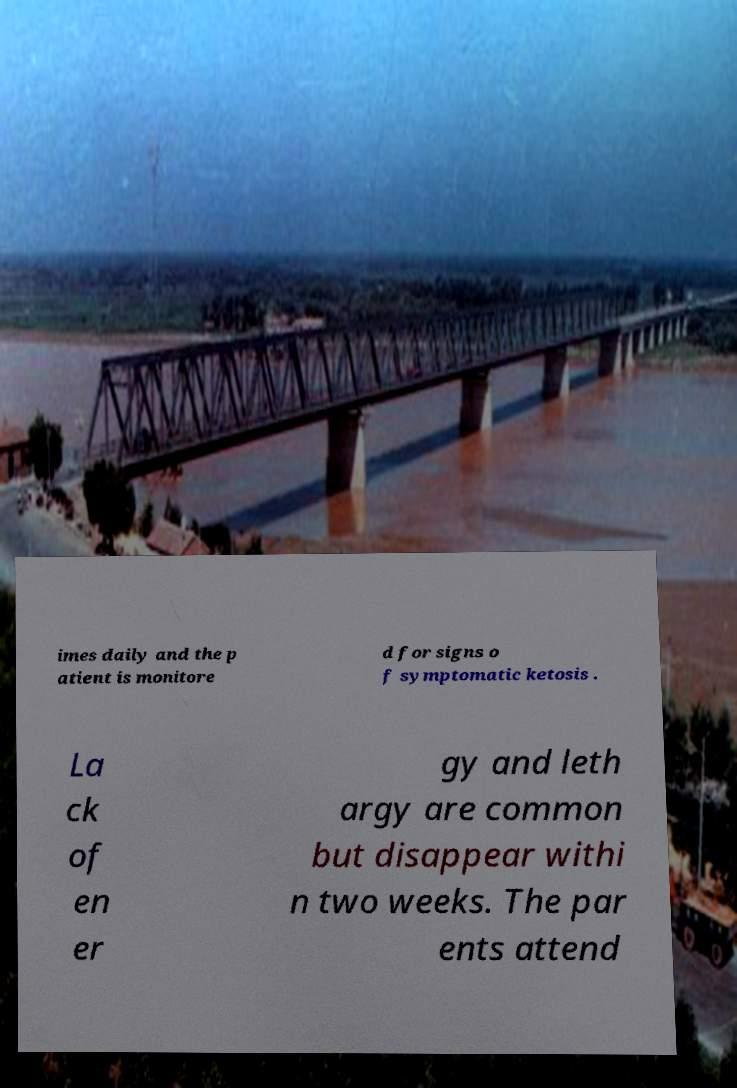What messages or text are displayed in this image? I need them in a readable, typed format. imes daily and the p atient is monitore d for signs o f symptomatic ketosis . La ck of en er gy and leth argy are common but disappear withi n two weeks. The par ents attend 